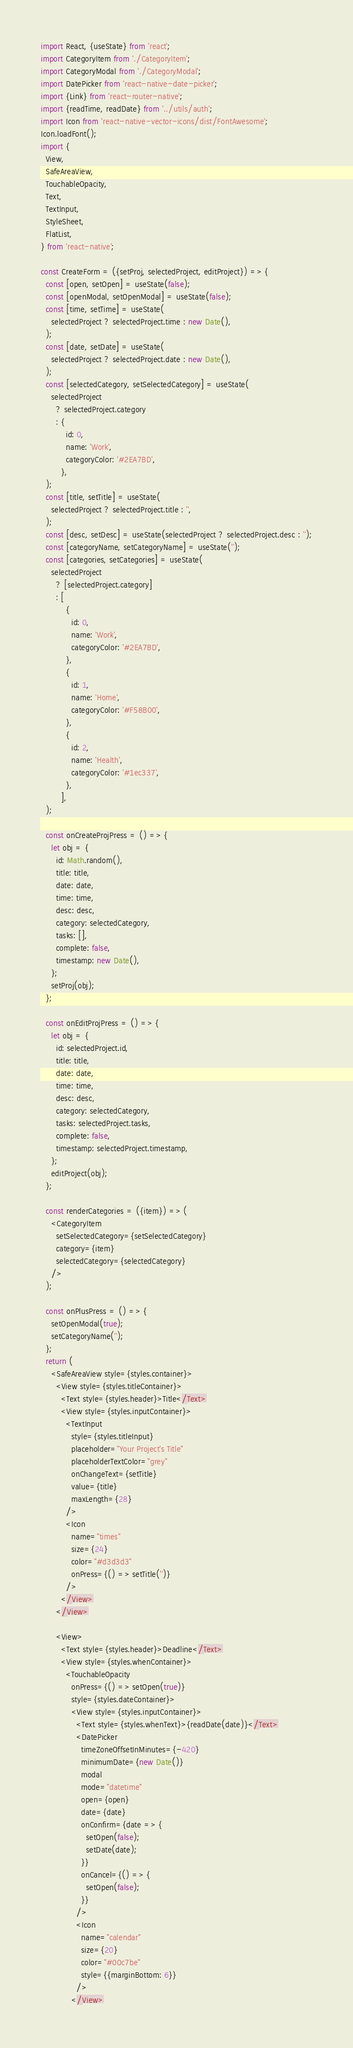Convert code to text. <code><loc_0><loc_0><loc_500><loc_500><_JavaScript_>import React, {useState} from 'react';
import CategoryItem from './CategoryItem';
import CategoryModal from './CategoryModal';
import DatePicker from 'react-native-date-picker';
import {Link} from 'react-router-native';
import {readTime, readDate} from '../utils/auth';
import Icon from 'react-native-vector-icons/dist/FontAwesome';
Icon.loadFont();
import {
  View,
  SafeAreaView,
  TouchableOpacity,
  Text,
  TextInput,
  StyleSheet,
  FlatList,
} from 'react-native';

const CreateForm = ({setProj, selectedProject, editProject}) => {
  const [open, setOpen] = useState(false);
  const [openModal, setOpenModal] = useState(false);
  const [time, setTime] = useState(
    selectedProject ? selectedProject.time : new Date(),
  );
  const [date, setDate] = useState(
    selectedProject ? selectedProject.date : new Date(),
  );
  const [selectedCategory, setSelectedCategory] = useState(
    selectedProject
      ? selectedProject.category
      : {
          id: 0,
          name: 'Work',
          categoryColor: '#2EA7BD',
        },
  );
  const [title, setTitle] = useState(
    selectedProject ? selectedProject.title : '',
  );
  const [desc, setDesc] = useState(selectedProject ? selectedProject.desc : '');
  const [categoryName, setCategoryName] = useState('');
  const [categories, setCategories] = useState(
    selectedProject
      ? [selectedProject.category]
      : [
          {
            id: 0,
            name: 'Work',
            categoryColor: '#2EA7BD',
          },
          {
            id: 1,
            name: 'Home',
            categoryColor: '#F58B00',
          },
          {
            id: 2,
            name: 'Health',
            categoryColor: '#1ec337',
          },
        ],
  );

  const onCreateProjPress = () => {
    let obj = {
      id: Math.random(),
      title: title,
      date: date,
      time: time,
      desc: desc,
      category: selectedCategory,
      tasks: [],
      complete: false,
      timestamp: new Date(),
    };
    setProj(obj);
  };

  const onEditProjPress = () => {
    let obj = {
      id: selectedProject.id,
      title: title,
      date: date,
      time: time,
      desc: desc,
      category: selectedCategory,
      tasks: selectedProject.tasks,
      complete: false,
      timestamp: selectedProject.timestamp,
    };
    editProject(obj);
  };

  const renderCategories = ({item}) => (
    <CategoryItem
      setSelectedCategory={setSelectedCategory}
      category={item}
      selectedCategory={selectedCategory}
    />
  );

  const onPlusPress = () => {
    setOpenModal(true);
    setCategoryName('');
  };
  return (
    <SafeAreaView style={styles.container}>
      <View style={styles.titleContainer}>
        <Text style={styles.header}>Title</Text>
        <View style={styles.inputContainer}>
          <TextInput
            style={styles.titleInput}
            placeholder="Your Project's Title"
            placeholderTextColor="grey"
            onChangeText={setTitle}
            value={title}
            maxLength={28}
          />
          <Icon
            name="times"
            size={24}
            color="#d3d3d3"
            onPress={() => setTitle('')}
          />
        </View>
      </View>

      <View>
        <Text style={styles.header}>Deadline</Text>
        <View style={styles.whenContainer}>
          <TouchableOpacity
            onPress={() => setOpen(true)}
            style={styles.dateContainer}>
            <View style={styles.inputContainer}>
              <Text style={styles.whenText}>{readDate(date)}</Text>
              <DatePicker
                timeZoneOffsetInMinutes={-420}
                minimumDate={new Date()}
                modal
                mode="datetime"
                open={open}
                date={date}
                onConfirm={date => {
                  setOpen(false);
                  setDate(date);
                }}
                onCancel={() => {
                  setOpen(false);
                }}
              />
              <Icon
                name="calendar"
                size={20}
                color="#00c7be"
                style={{marginBottom: 6}}
              />
            </View></code> 